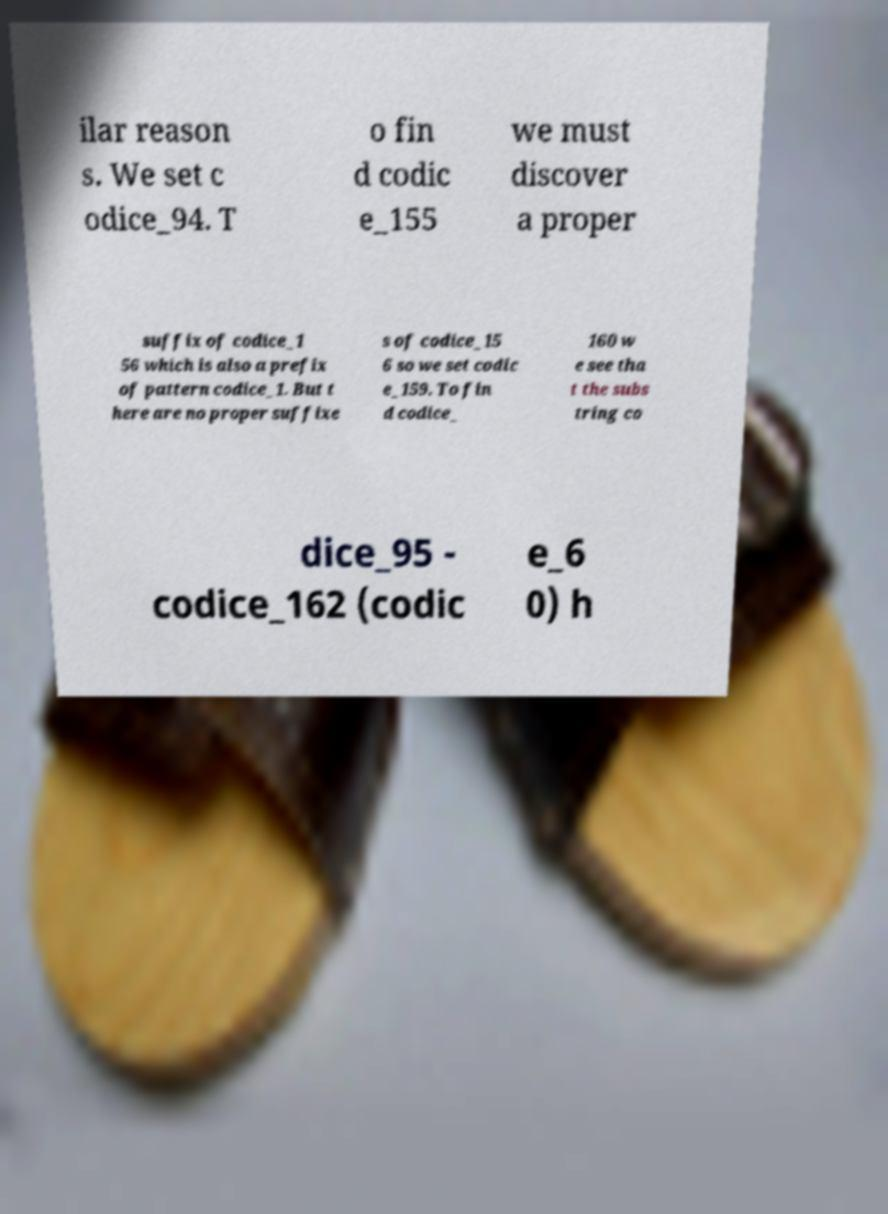Could you extract and type out the text from this image? ilar reason s. We set c odice_94. T o fin d codic e_155 we must discover a proper suffix of codice_1 56 which is also a prefix of pattern codice_1. But t here are no proper suffixe s of codice_15 6 so we set codic e_159. To fin d codice_ 160 w e see tha t the subs tring co dice_95 - codice_162 (codic e_6 0) h 